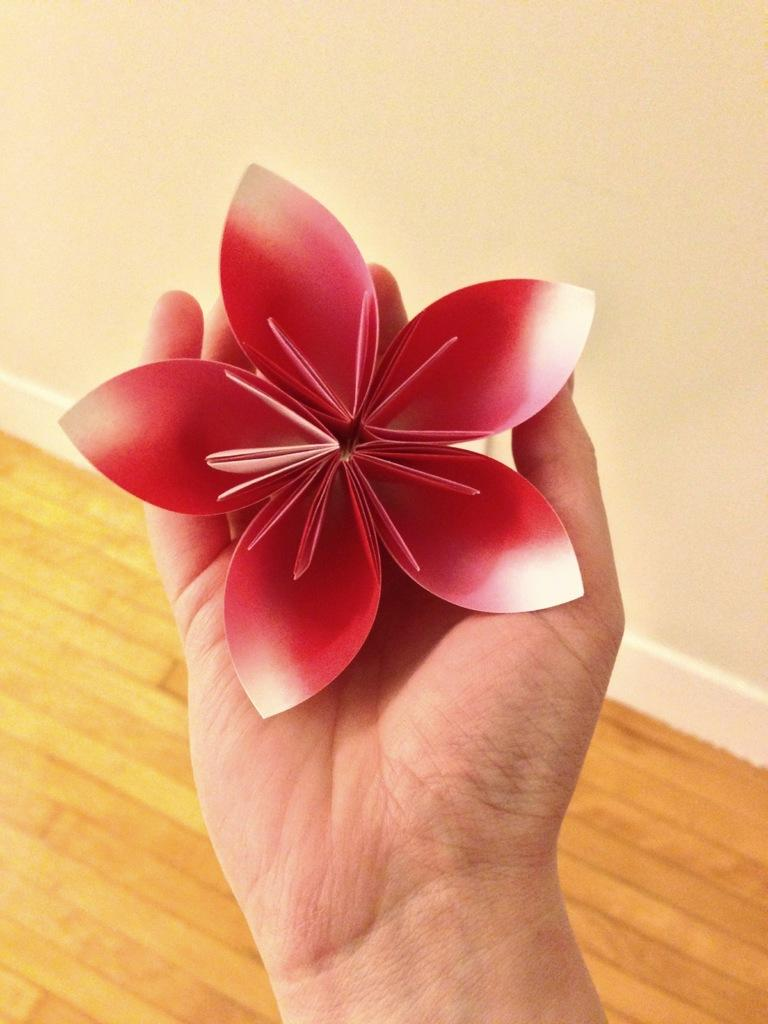What is the person holding in the image? The person's hand is holding a red color paper rose in the image. Can you describe the color of the object being held? The object being held is a red color paper rose. What type of flooring is visible in the background of the image? There is a wooden floor visible in the background of the image. What color is the wall in the background of the image? The wall in the background of the image is white in color. Are there any horses visible in the image? No, there are no horses present in the image. Can you tell me if the person is driving a vehicle in the image? No, there is no indication of a vehicle or driving in the image. 